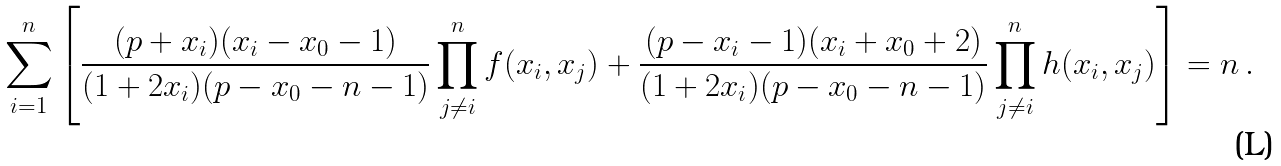Convert formula to latex. <formula><loc_0><loc_0><loc_500><loc_500>\sum _ { i = 1 } ^ { n } \left [ \frac { ( p + x _ { i } ) ( x _ { i } - x _ { 0 } - 1 ) } { ( 1 + 2 x _ { i } ) ( p - x _ { 0 } - n - 1 ) } \prod _ { j \neq i } ^ { n } f ( x _ { i } , x _ { j } ) + \frac { ( p - x _ { i } - 1 ) ( x _ { i } + x _ { 0 } + 2 ) } { ( 1 + 2 x _ { i } ) ( p - x _ { 0 } - n - 1 ) } \prod _ { j \neq i } ^ { n } h ( x _ { i } , x _ { j } ) \right ] & = n \, .</formula> 